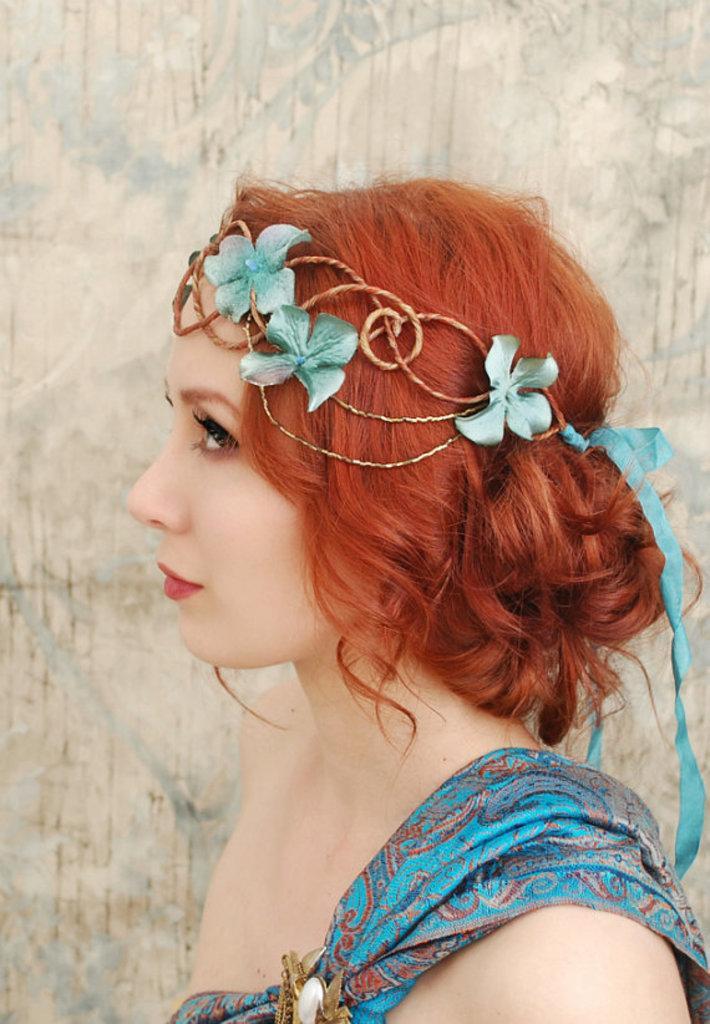Please provide a concise description of this image. In this image I see a woman and I see that she is wearing blue dress and I see a tiara on her head and I see the wall in the background. 